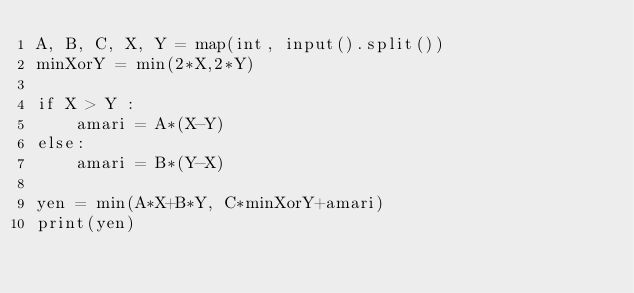<code> <loc_0><loc_0><loc_500><loc_500><_Python_>A, B, C, X, Y = map(int, input().split())
minXorY = min(2*X,2*Y)

if X > Y :
    amari = A*(X-Y)
else:
    amari = B*(Y-X)

yen = min(A*X+B*Y, C*minXorY+amari)
print(yen)</code> 